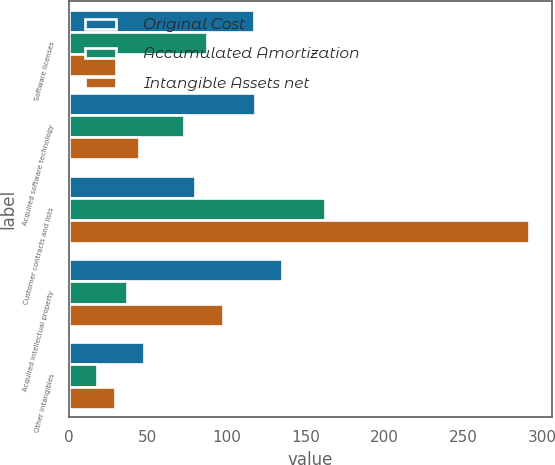<chart> <loc_0><loc_0><loc_500><loc_500><stacked_bar_chart><ecel><fcel>Software licenses<fcel>Acquired software technology<fcel>Customer contracts and lists<fcel>Acquired intellectual property<fcel>Other intangibles<nl><fcel>Original Cost<fcel>117.5<fcel>117.8<fcel>80.25<fcel>135<fcel>47.7<nl><fcel>Accumulated Amortization<fcel>87.5<fcel>73<fcel>162.1<fcel>36.9<fcel>18.2<nl><fcel>Intangible Assets net<fcel>30<fcel>44.8<fcel>291.7<fcel>98.1<fcel>29.5<nl></chart> 